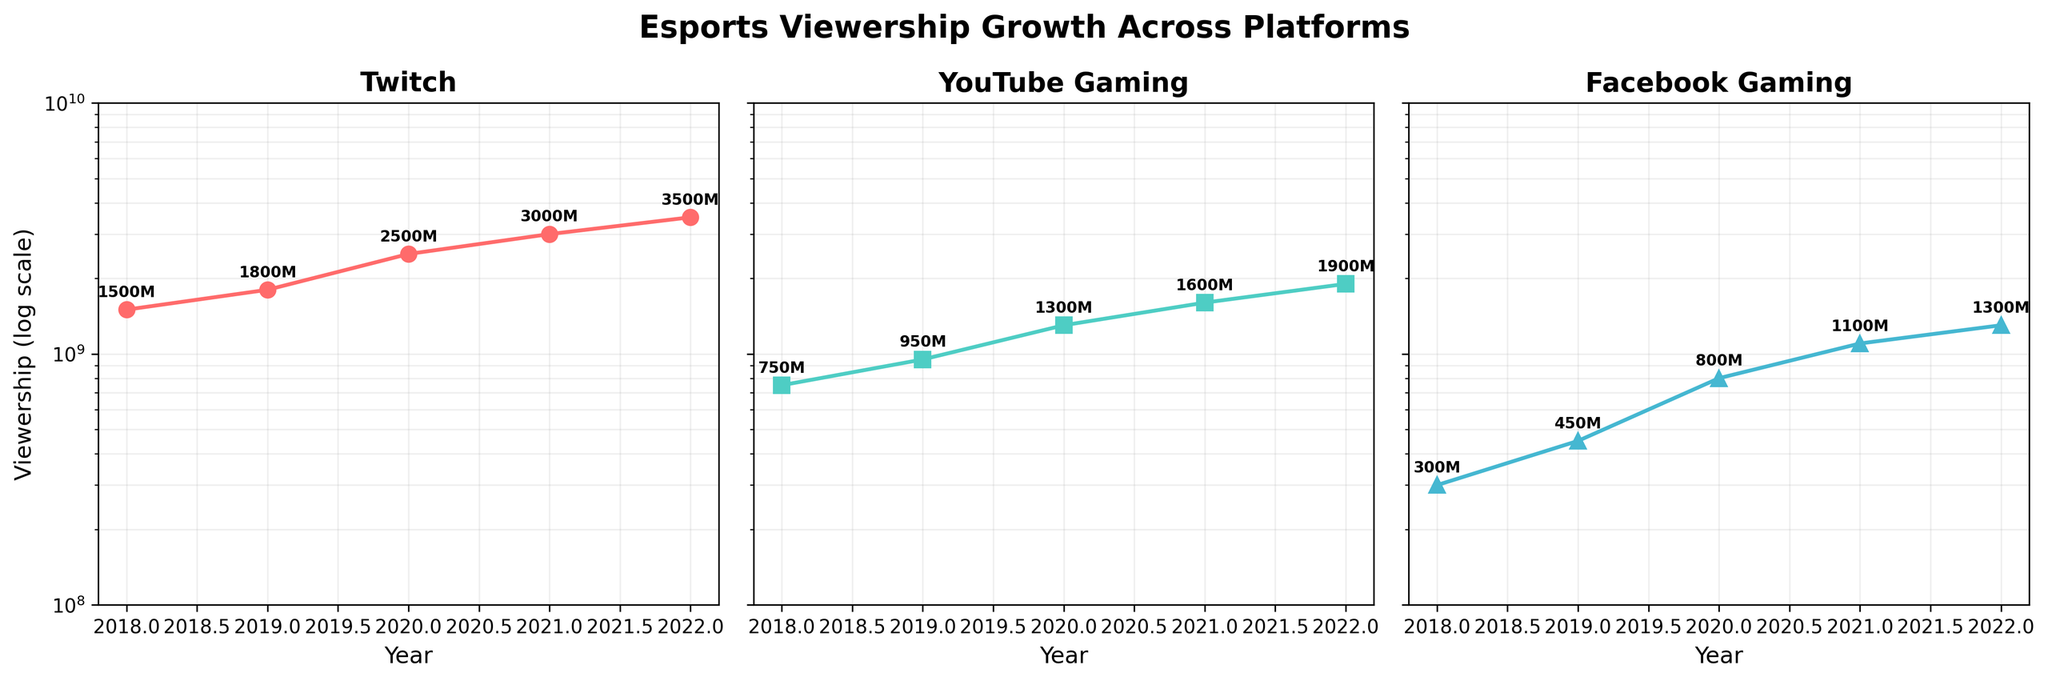What's the title of the figure? The title is displayed at the top of the figure and reads "Esports Viewership Growth Across Platforms".
Answer: Esports Viewership Growth Across Platforms Which platform had the highest viewership in 2022? By examining the topmost data points in 2022 across all subplots, Twitch shows the highest viewership with 3.5 billion.
Answer: Twitch How does the viewership growth trend of Facebook Gaming appear from 2018 to 2022? By following the data points in the subplot for Facebook Gaming, the viewership has been steadily increasing each year.
Answer: Increasing What is the viewership difference between Twitch and YouTube Gaming in 2018? In 2018, Twitch had 1.5 billion and YouTube Gaming had 0.75 billion viewers. The difference (1.5 billion - 0.75 billion) is 0.75 billion.
Answer: 0.75 billion What is the average viewership for YouTube Gaming from 2018 to 2022? Summing the YouTube Gaming data points (750M + 950M + 1300M + 1600M + 1900M) gives 6500M. Dividing by 5 years gives an average of 1300M or 1.3 billion.
Answer: 1.3 billion Which year saw the highest growth rate for Twitch? By comparing the year-to-year growth in the Twitch subplot, the highest growth appears between 2019 and 2020 (1.8 billion to 2.5 billion, growth of 0.7 billion).
Answer: 2020 Compare the viewership trends between Twitch and Facebook Gaming from 2018 to 2022. Both platforms show an increasing trend, but Twitch grows more rapidly. In 2018 Facebook Gaming had 300M viewers increasing to 1300M in 2022, while Twitch grew from 1500M to 3500M.
Answer: Twitch grew faster What trend can be observed for the YouTube Gaming platform viewership between 2020 and 2022? The data points show a steady increase from 1.3 billion to 1.9 billion across these years.
Answer: Steady increase Which platform had the smallest viewer base in 2018? By looking at the 2018 data points, Facebook Gaming had the smallest viewership with 300 million.
Answer: Facebook Gaming How is the y-axis scaled and what does this imply about the presentation of data? The y-axis is logarithmically scaled, meaning each unit step represents a tenfold change, which helps in displaying data spanning several orders of magnitude more clearly.
Answer: Logarithmic scale 